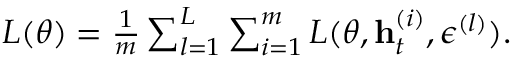<formula> <loc_0><loc_0><loc_500><loc_500>\begin{array} { r } { L ( \theta ) = \frac { 1 } { m } \sum _ { l = 1 } ^ { L } \sum _ { i = 1 } ^ { m } L ( \theta , h _ { t } ^ { ( i ) } , \epsilon ^ { ( l ) } ) . } \end{array}</formula> 